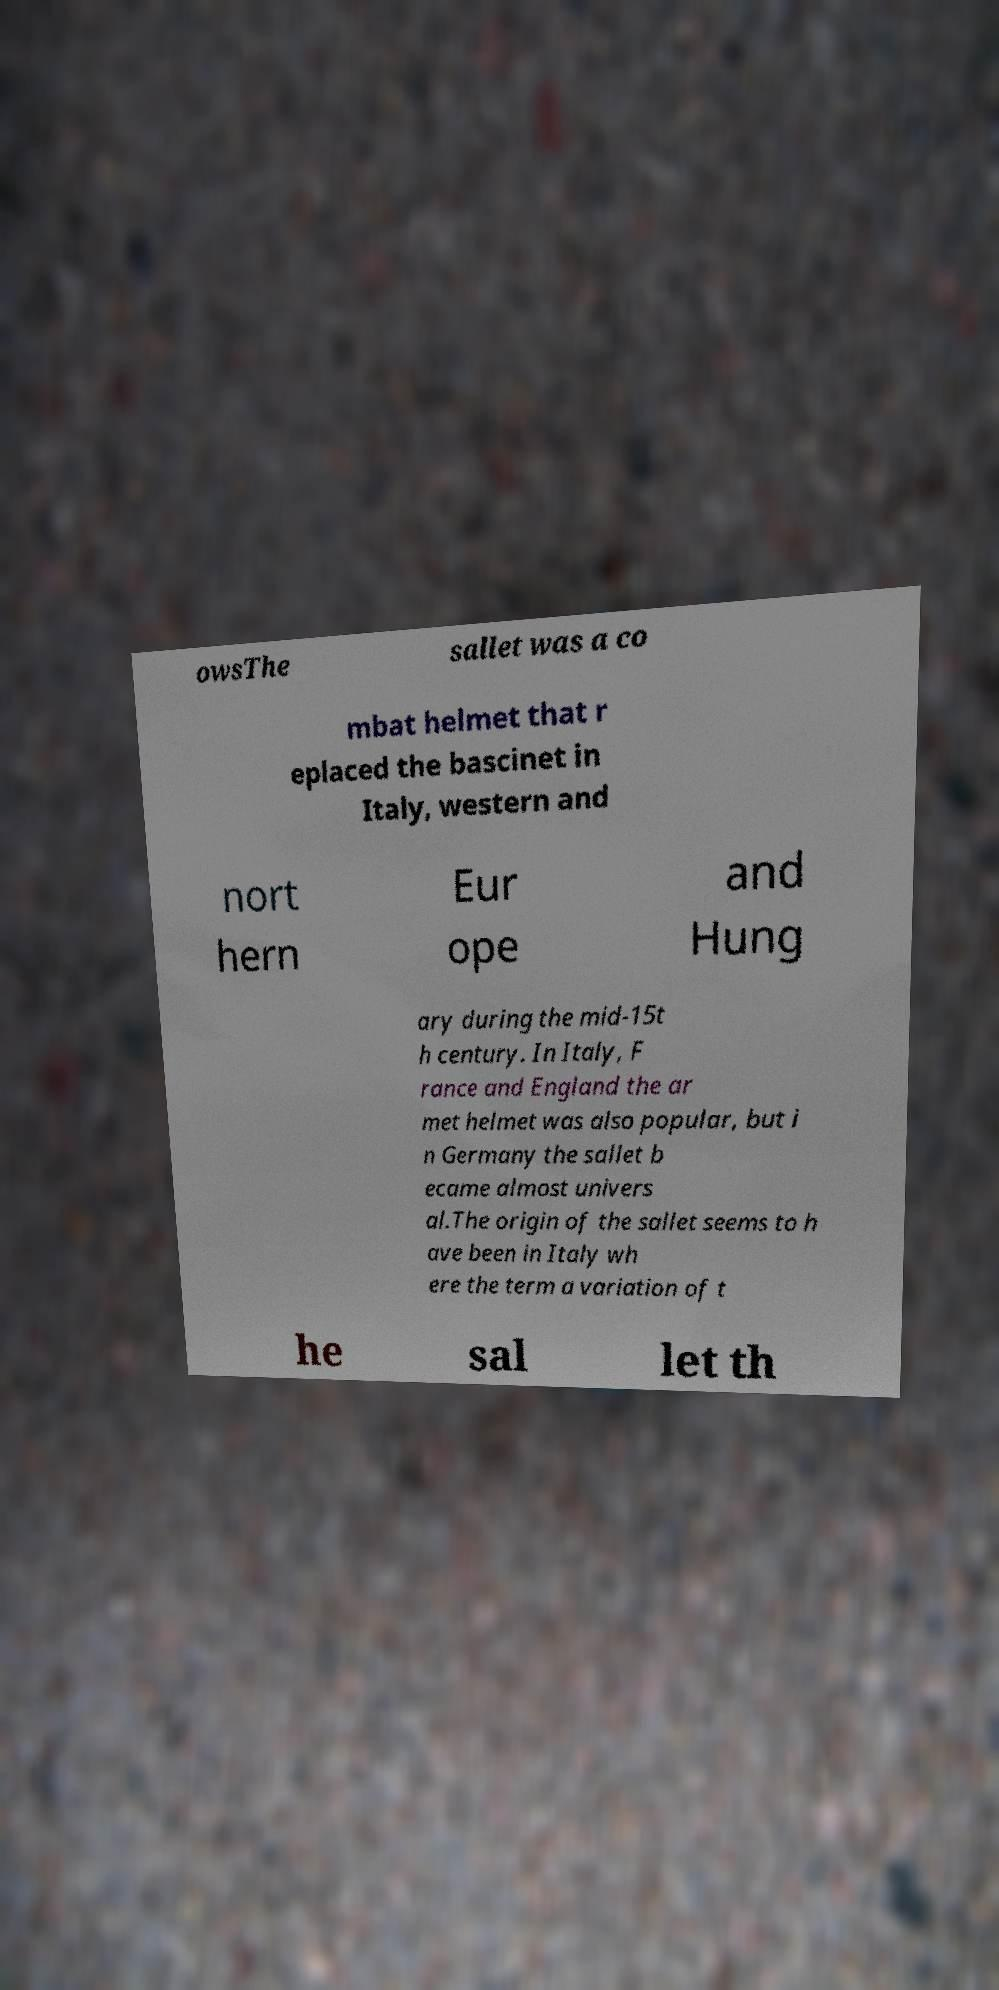For documentation purposes, I need the text within this image transcribed. Could you provide that? owsThe sallet was a co mbat helmet that r eplaced the bascinet in Italy, western and nort hern Eur ope and Hung ary during the mid-15t h century. In Italy, F rance and England the ar met helmet was also popular, but i n Germany the sallet b ecame almost univers al.The origin of the sallet seems to h ave been in Italy wh ere the term a variation of t he sal let th 